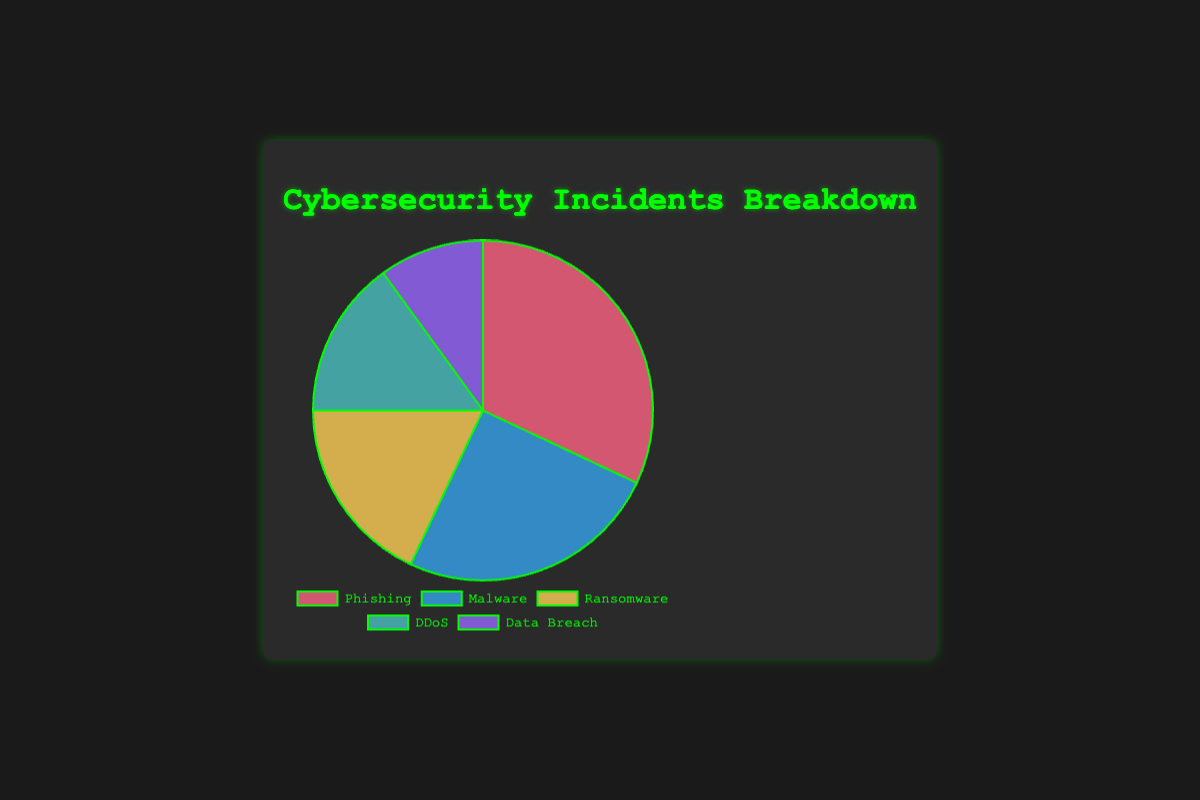Which type of cybersecurity incident is the most common? By looking at the pie chart, you can see which slice is the largest. Phishing has the largest slice.
Answer: Phishing Which two types of incidents together account for more than half of all incidents? The percentages of Phishing and Malware are 32% and 25%, respectively. Together, they sum up to 57%, which is more than half.
Answer: Phishing and Malware What is the difference in percentage between the most common and least common types of incidents? Phishing accounts for 32% and Data Breach accounts for 10%. The difference is 32% - 10% = 22%.
Answer: 22% If you combine the percentages of Ransomware and DDoS, does it exceed the percentage of Malware incidents? Ransomware is 18% and DDoS is 15%, together they are 18% + 15% = 33%, which is greater than Malware's 25%.
Answer: Yes What is the combined percentage of incidents attributed to DDoS and Data Breach? Add the percentages of DDoS and Data Breach: 15% + 10% = 25%.
Answer: 25% Which incident type is represented by a blue slice in the pie chart? By referring to the pie chart's legend, Malware is represented by the blue slice.
Answer: Malware How many more percentage points do Phishing incidents have compared to Ransomware incidents? Phishing is at 32% and Ransomware is at 18%. The difference is 32% - 18% = 14%.
Answer: 14% Which incident type contributes the smallest percentage in the pie chart? By looking at the pie chart, the smallest slice corresponds to Data Breach with 10%.
Answer: Data Breach Are the incidents attributed to Phishing and Malware more than twice the incidents attributed to Ransomware? The sum of Phishing and Malware percentages is 32% + 25% = 57%, which is more than twice (2 * 18% = 36%) of Ransomware's 18%.
Answer: Yes What is the average percentage of the incidents across the five types? Sum all the percentages: 32% + 25% + 18% + 15% + 10% = 100%, then divide by 5: 100% / 5 = 20%.
Answer: 20% 